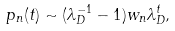<formula> <loc_0><loc_0><loc_500><loc_500>p _ { n } ( t ) \sim ( \lambda _ { D } ^ { - 1 } - 1 ) w _ { n } \lambda _ { D } ^ { t } ,</formula> 